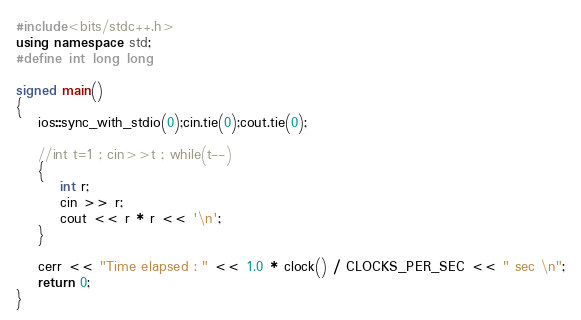<code> <loc_0><loc_0><loc_500><loc_500><_C++_>
#include<bits/stdc++.h>
using namespace std;
#define int long long

signed main()
{
    ios::sync_with_stdio(0);cin.tie(0);cout.tie(0);
    
    //int t=1 ; cin>>t ; while(t--)
    {
    	int r;
    	cin >> r;
    	cout << r * r << '\n';
    }
    
    cerr << "Time elapsed : " << 1.0 * clock() / CLOCKS_PER_SEC << " sec \n";
    return 0;
}

</code> 